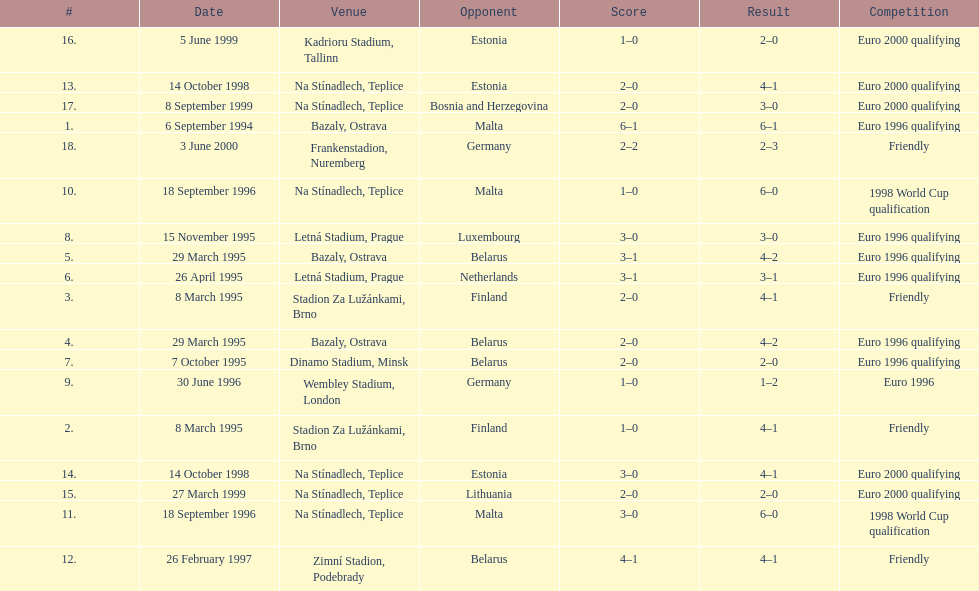How many total games took place in 1999? 3. 